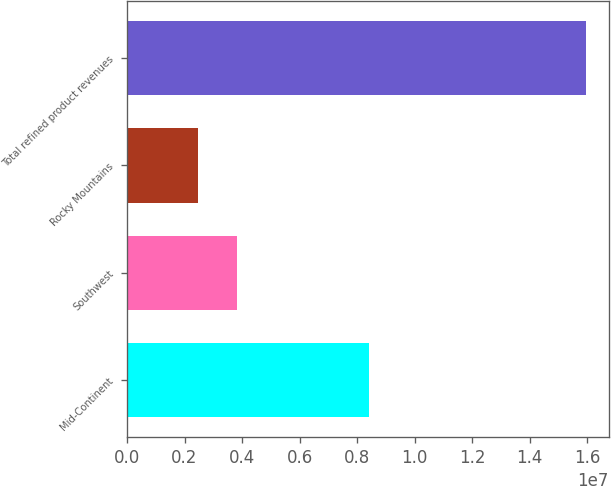Convert chart. <chart><loc_0><loc_0><loc_500><loc_500><bar_chart><fcel>Mid-Continent<fcel>Southwest<fcel>Rocky Mountains<fcel>Total refined product revenues<nl><fcel>8.4272e+06<fcel>3.82331e+06<fcel>2.47604e+06<fcel>1.59487e+07<nl></chart> 